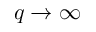<formula> <loc_0><loc_0><loc_500><loc_500>q \to \infty</formula> 